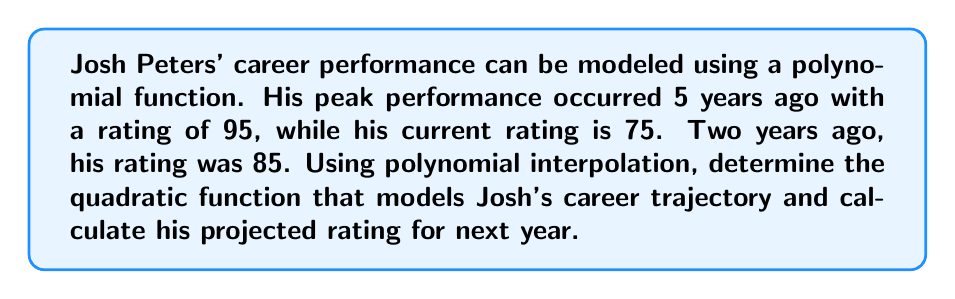Give your solution to this math problem. Let's approach this step-by-step using quadratic polynomial interpolation:

1) We'll use the quadratic function $f(x) = ax^2 + bx + c$, where $x$ represents the number of years from his peak performance.

2) We have three points:
   $(0, 95)$ - peak performance 5 years ago
   $(3, 85)$ - performance 2 years ago
   $(5, 75)$ - current performance

3) Substituting these points into the quadratic function:
   $95 = a(0)^2 + b(0) + c$
   $85 = a(3)^2 + b(3) + c$
   $75 = a(5)^2 + b(5) + c$

4) From the first equation: $c = 95$

5) Substituting this into the other two equations:
   $85 = 9a + 3b + 95$
   $75 = 25a + 5b + 95$

6) Simplifying:
   $-10 = 9a + 3b$
   $-20 = 25a + 5b$

7) Multiply the first equation by 5 and the second by -3:
   $-50 = 45a + 15b$
   $60 = -75a - 15b$

8) Adding these equations:
   $10 = -30a$
   $a = -\frac{1}{3}$

9) Substituting this back into $-10 = 9a + 3b$:
   $-10 = 9(-\frac{1}{3}) + 3b$
   $-10 = -3 + 3b$
   $-7 = 3b$
   $b = -\frac{7}{3}$

10) Therefore, the quadratic function is:
    $f(x) = -\frac{1}{3}x^2 - \frac{7}{3}x + 95$

11) To project next year's rating, we calculate $f(6)$:
    $f(6) = -\frac{1}{3}(6)^2 - \frac{7}{3}(6) + 95$
    $= -12 - 14 + 95$
    $= 69$
Answer: Josh Peters' career trajectory can be modeled by the quadratic function $f(x) = -\frac{1}{3}x^2 - \frac{7}{3}x + 95$, where $x$ is the number of years from his peak performance. His projected rating for next year is 69. 